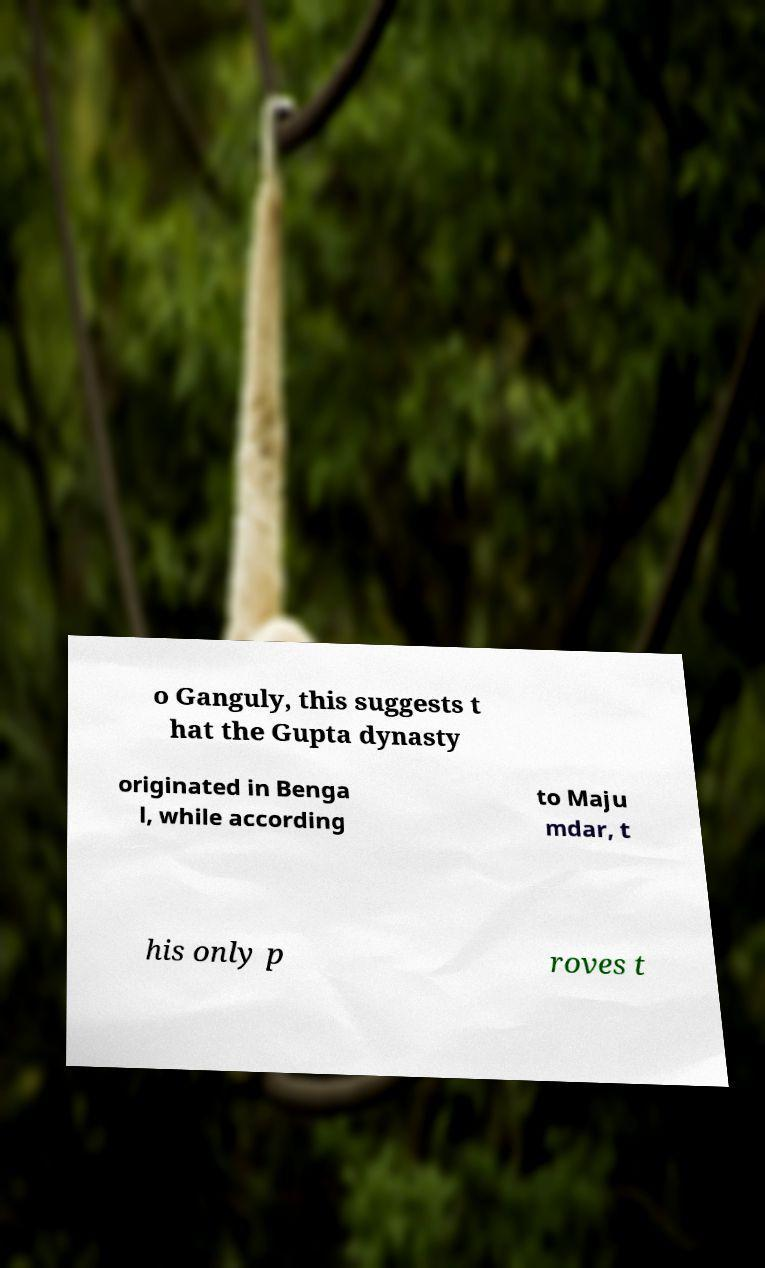Please read and relay the text visible in this image. What does it say? o Ganguly, this suggests t hat the Gupta dynasty originated in Benga l, while according to Maju mdar, t his only p roves t 